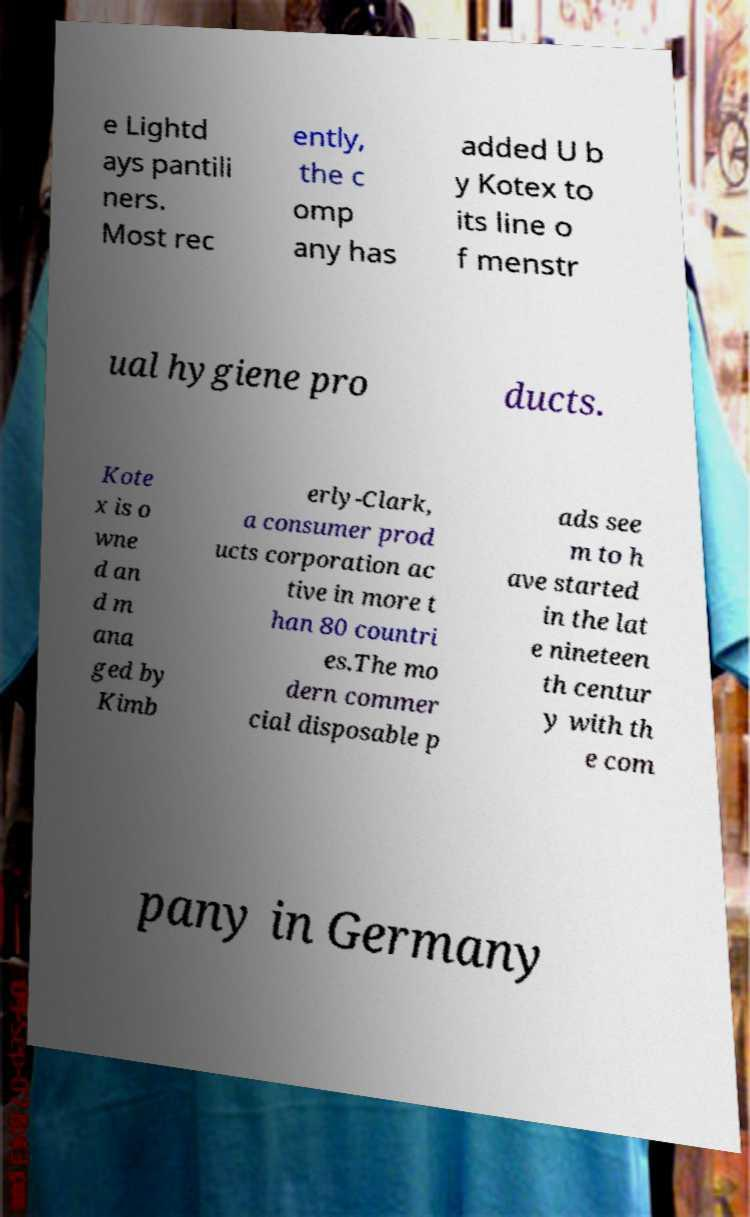Could you assist in decoding the text presented in this image and type it out clearly? e Lightd ays pantili ners. Most rec ently, the c omp any has added U b y Kotex to its line o f menstr ual hygiene pro ducts. Kote x is o wne d an d m ana ged by Kimb erly-Clark, a consumer prod ucts corporation ac tive in more t han 80 countri es.The mo dern commer cial disposable p ads see m to h ave started in the lat e nineteen th centur y with th e com pany in Germany 